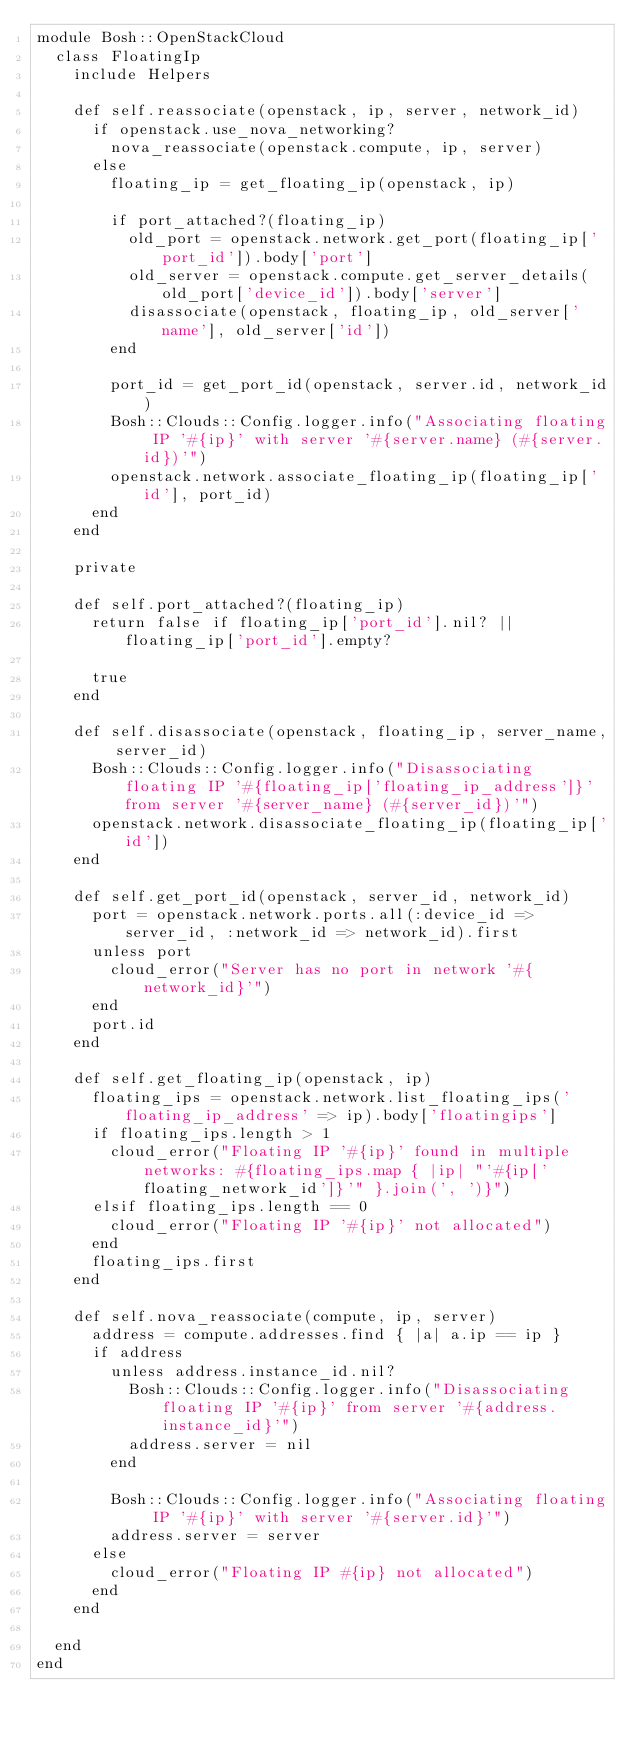<code> <loc_0><loc_0><loc_500><loc_500><_Ruby_>module Bosh::OpenStackCloud
  class FloatingIp
    include Helpers

    def self.reassociate(openstack, ip, server, network_id)
      if openstack.use_nova_networking?
        nova_reassociate(openstack.compute, ip, server)
      else
        floating_ip = get_floating_ip(openstack, ip)

        if port_attached?(floating_ip)
          old_port = openstack.network.get_port(floating_ip['port_id']).body['port']
          old_server = openstack.compute.get_server_details(old_port['device_id']).body['server']
          disassociate(openstack, floating_ip, old_server['name'], old_server['id'])
        end

        port_id = get_port_id(openstack, server.id, network_id)
        Bosh::Clouds::Config.logger.info("Associating floating IP '#{ip}' with server '#{server.name} (#{server.id})'")
        openstack.network.associate_floating_ip(floating_ip['id'], port_id)
      end
    end

    private

    def self.port_attached?(floating_ip)
      return false if floating_ip['port_id'].nil? || floating_ip['port_id'].empty?

      true
    end

    def self.disassociate(openstack, floating_ip, server_name, server_id)
      Bosh::Clouds::Config.logger.info("Disassociating floating IP '#{floating_ip['floating_ip_address']}' from server '#{server_name} (#{server_id})'")
      openstack.network.disassociate_floating_ip(floating_ip['id'])
    end

    def self.get_port_id(openstack, server_id, network_id)
      port = openstack.network.ports.all(:device_id => server_id, :network_id => network_id).first
      unless port
        cloud_error("Server has no port in network '#{network_id}'")
      end
      port.id
    end

    def self.get_floating_ip(openstack, ip)
      floating_ips = openstack.network.list_floating_ips('floating_ip_address' => ip).body['floatingips']
      if floating_ips.length > 1
        cloud_error("Floating IP '#{ip}' found in multiple networks: #{floating_ips.map { |ip| "'#{ip['floating_network_id']}'" }.join(', ')}")
      elsif floating_ips.length == 0
        cloud_error("Floating IP '#{ip}' not allocated")
      end
      floating_ips.first
    end

    def self.nova_reassociate(compute, ip, server)
      address = compute.addresses.find { |a| a.ip == ip }
      if address
        unless address.instance_id.nil?
          Bosh::Clouds::Config.logger.info("Disassociating floating IP '#{ip}' from server '#{address.instance_id}'")
          address.server = nil
        end

        Bosh::Clouds::Config.logger.info("Associating floating IP '#{ip}' with server '#{server.id}'")
        address.server = server
      else
        cloud_error("Floating IP #{ip} not allocated")
      end
    end

  end
end
</code> 